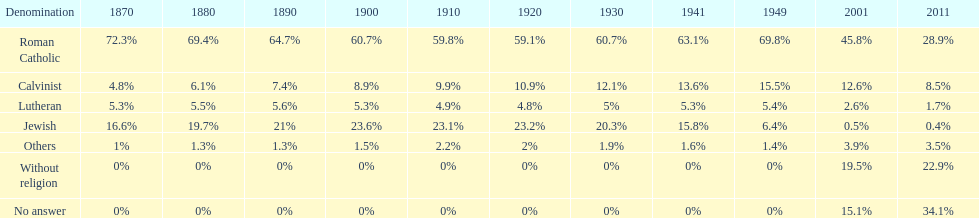In which year was the percentage of those without religion at least 20%? 2011. 